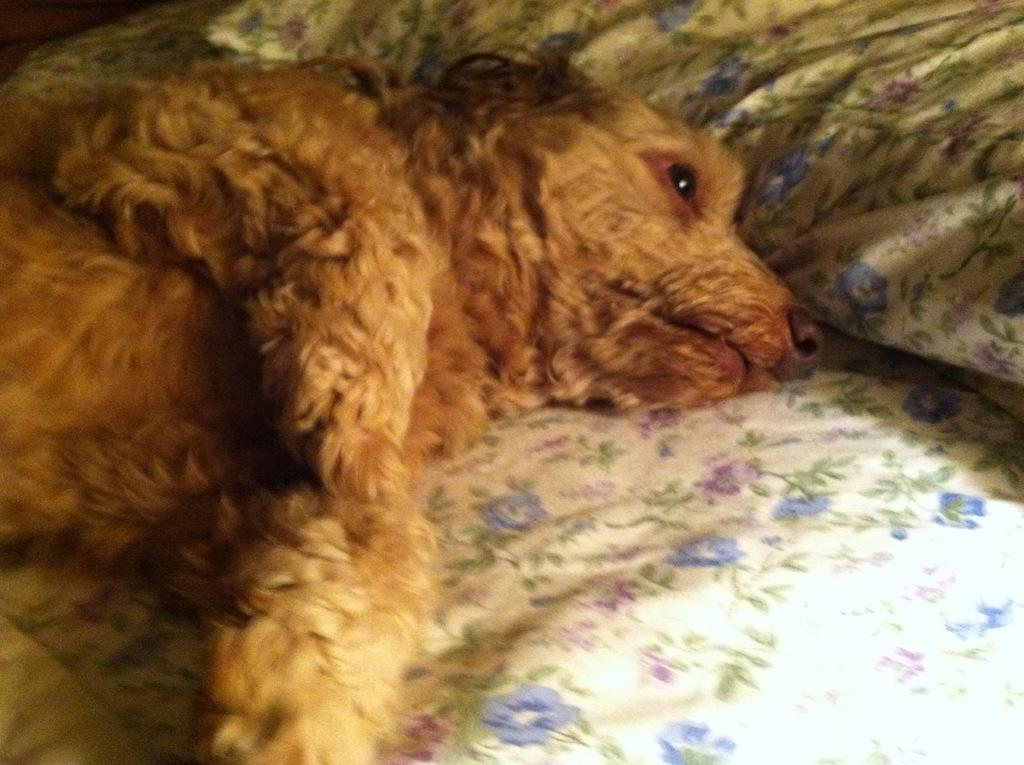What is the main subject in the center of the image? There is an animal in the center of the image. What is located at the bottom of the image? There is a bed at the bottom of the image. What is covering the bed? There is a blanket on the bed. What is supporting the head of the animal on the bed? There is a pillow on the bed. What type of linen is used to make the guide's uniform in the image? There is no guide or uniform present in the image; it features an animal on a bed with a blanket and pillow. 